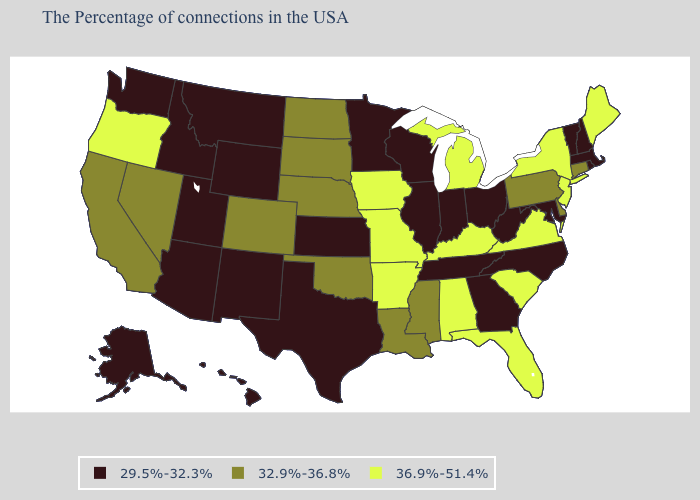Name the states that have a value in the range 36.9%-51.4%?
Give a very brief answer. Maine, New York, New Jersey, Virginia, South Carolina, Florida, Michigan, Kentucky, Alabama, Missouri, Arkansas, Iowa, Oregon. Name the states that have a value in the range 32.9%-36.8%?
Be succinct. Connecticut, Delaware, Pennsylvania, Mississippi, Louisiana, Nebraska, Oklahoma, South Dakota, North Dakota, Colorado, Nevada, California. Name the states that have a value in the range 29.5%-32.3%?
Quick response, please. Massachusetts, Rhode Island, New Hampshire, Vermont, Maryland, North Carolina, West Virginia, Ohio, Georgia, Indiana, Tennessee, Wisconsin, Illinois, Minnesota, Kansas, Texas, Wyoming, New Mexico, Utah, Montana, Arizona, Idaho, Washington, Alaska, Hawaii. Which states have the lowest value in the USA?
Short answer required. Massachusetts, Rhode Island, New Hampshire, Vermont, Maryland, North Carolina, West Virginia, Ohio, Georgia, Indiana, Tennessee, Wisconsin, Illinois, Minnesota, Kansas, Texas, Wyoming, New Mexico, Utah, Montana, Arizona, Idaho, Washington, Alaska, Hawaii. Among the states that border North Dakota , which have the lowest value?
Be succinct. Minnesota, Montana. What is the value of New York?
Give a very brief answer. 36.9%-51.4%. What is the value of Missouri?
Quick response, please. 36.9%-51.4%. What is the value of Vermont?
Concise answer only. 29.5%-32.3%. Does Florida have the highest value in the South?
Write a very short answer. Yes. What is the highest value in states that border Utah?
Give a very brief answer. 32.9%-36.8%. What is the lowest value in the USA?
Write a very short answer. 29.5%-32.3%. How many symbols are there in the legend?
Quick response, please. 3. What is the value of California?
Answer briefly. 32.9%-36.8%. 